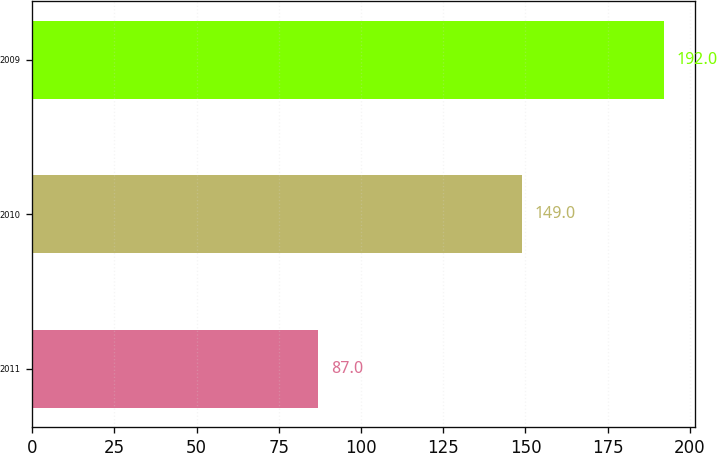<chart> <loc_0><loc_0><loc_500><loc_500><bar_chart><fcel>2011<fcel>2010<fcel>2009<nl><fcel>87<fcel>149<fcel>192<nl></chart> 